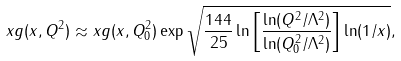<formula> <loc_0><loc_0><loc_500><loc_500>x g ( x , Q ^ { 2 } ) \approx x g ( x , Q _ { 0 } ^ { 2 } ) \exp \sqrt { \frac { 1 4 4 } { 2 5 } \ln \left [ \frac { \ln ( Q ^ { 2 } / \Lambda ^ { 2 } ) } { \ln ( Q _ { 0 } ^ { 2 } / \Lambda ^ { 2 } ) } \right ] \ln ( 1 / x ) } ,</formula> 